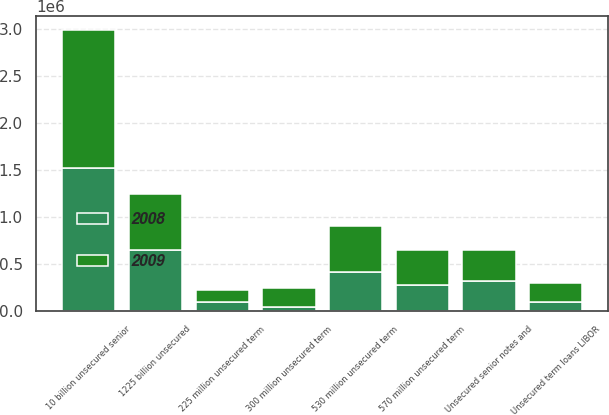Convert chart to OTSL. <chart><loc_0><loc_0><loc_500><loc_500><stacked_bar_chart><ecel><fcel>1225 billion unsecured<fcel>Unsecured senior notes and<fcel>10 billion unsecured senior<fcel>300 million unsecured term<fcel>Unsecured term loans LIBOR<fcel>225 million unsecured term<fcel>570 million unsecured term<fcel>530 million unsecured term<nl><fcel>2008<fcel>650000<fcel>325714<fcel>1.52613e+06<fcel>50000<fcel>100000<fcel>96390<fcel>285000<fcel>416429<nl><fcel>2009<fcel>600000<fcel>325714<fcel>1.46378e+06<fcel>200000<fcel>200000<fcel>128543<fcel>366429<fcel>492143<nl></chart> 